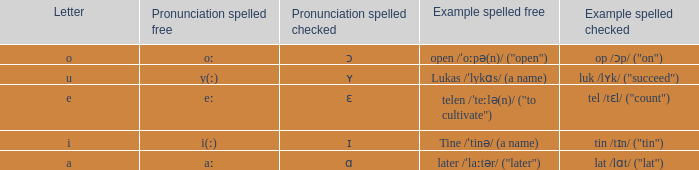What is Letter, when Example Spelled Checked is "tin /tɪn/ ("tin")"? I. 